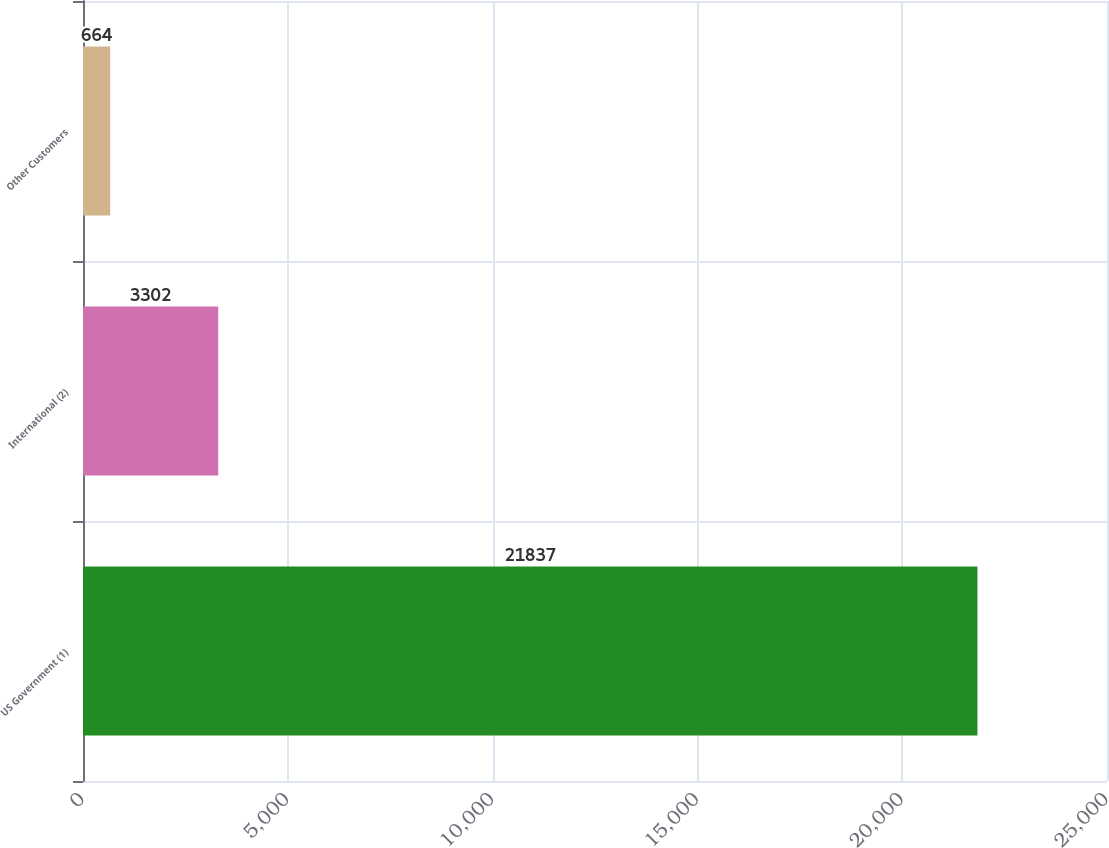Convert chart to OTSL. <chart><loc_0><loc_0><loc_500><loc_500><bar_chart><fcel>US Government (1)<fcel>International (2)<fcel>Other Customers<nl><fcel>21837<fcel>3302<fcel>664<nl></chart> 